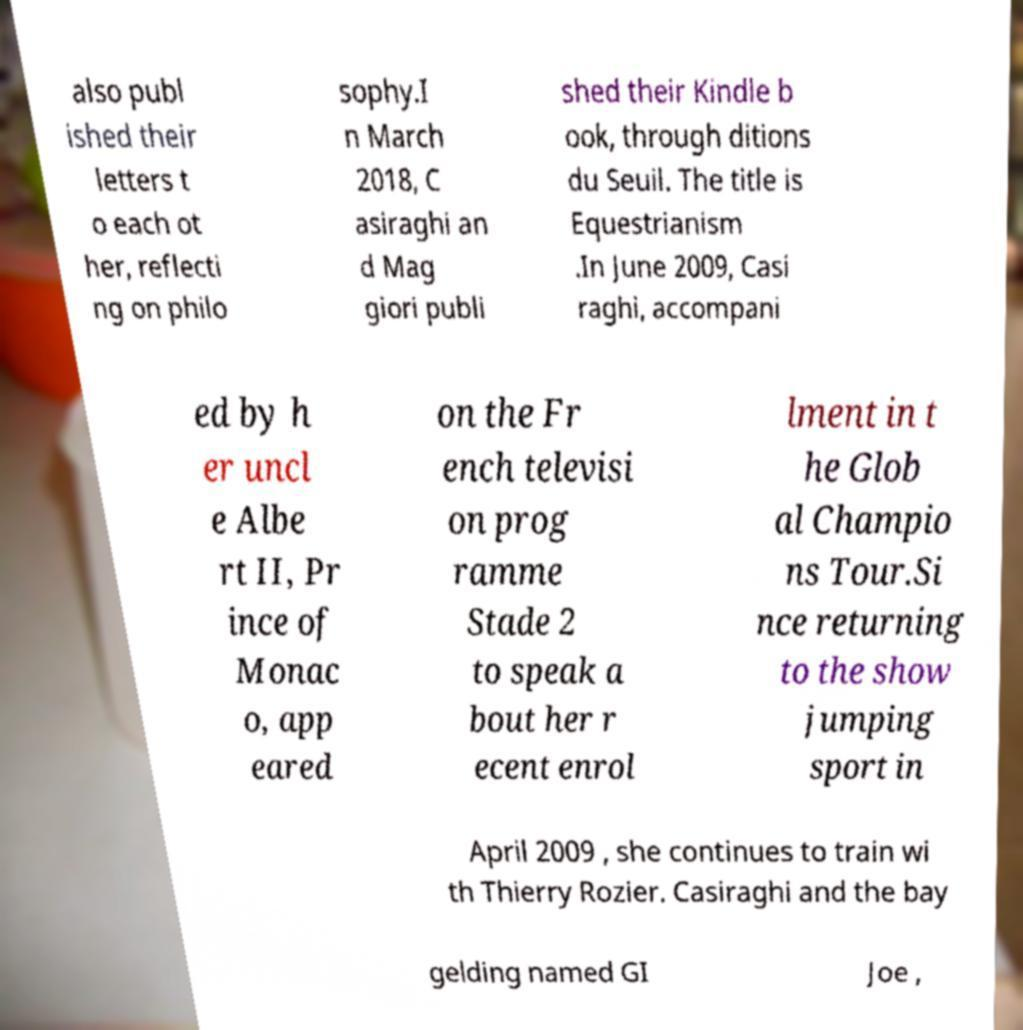For documentation purposes, I need the text within this image transcribed. Could you provide that? also publ ished their letters t o each ot her, reflecti ng on philo sophy.I n March 2018, C asiraghi an d Mag giori publi shed their Kindle b ook, through ditions du Seuil. The title is Equestrianism .In June 2009, Casi raghi, accompani ed by h er uncl e Albe rt II, Pr ince of Monac o, app eared on the Fr ench televisi on prog ramme Stade 2 to speak a bout her r ecent enrol lment in t he Glob al Champio ns Tour.Si nce returning to the show jumping sport in April 2009 , she continues to train wi th Thierry Rozier. Casiraghi and the bay gelding named GI Joe , 